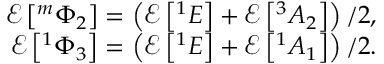Convert formula to latex. <formula><loc_0><loc_0><loc_500><loc_500>\begin{array} { r } { \mathcal { E } \left [ ^ { m } \Phi _ { 2 } \right ] = \left ( \mathcal { E } \left [ ^ { 1 } E \right ] + \mathcal { E } \left [ ^ { 3 } A _ { 2 } \right ] \right ) / 2 , } \\ { \mathcal { E } \left [ ^ { 1 } \Phi _ { 3 } \right ] = \left ( \mathcal { E } \left [ ^ { 1 } E \right ] + \mathcal { E } \left [ ^ { 1 } A _ { 1 } \right ] \right ) / 2 . } \end{array}</formula> 